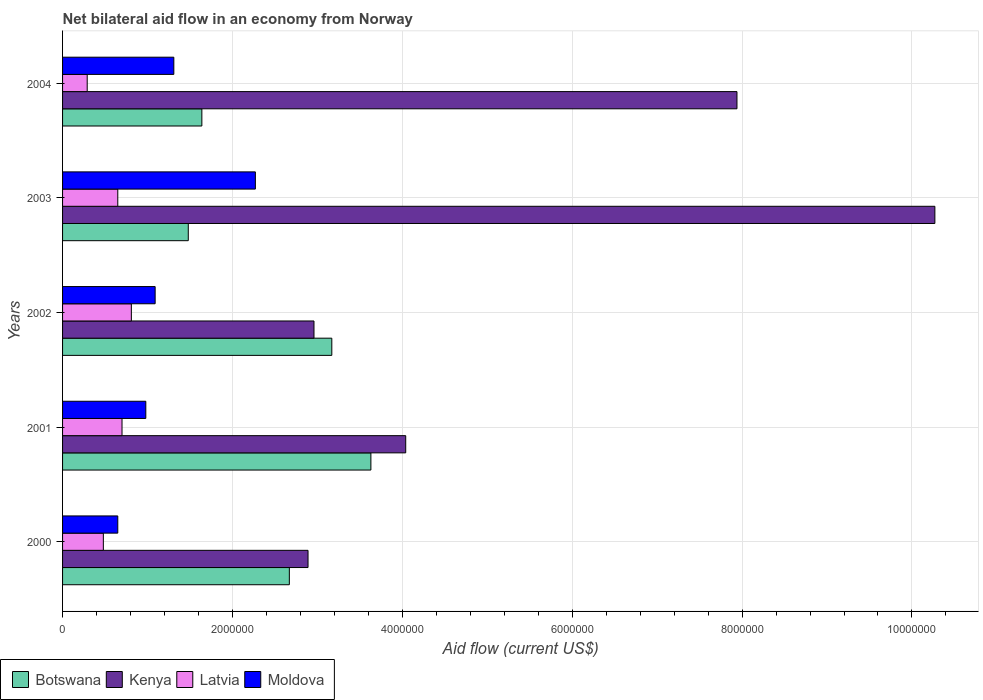Are the number of bars on each tick of the Y-axis equal?
Give a very brief answer. Yes. How many bars are there on the 5th tick from the top?
Give a very brief answer. 4. How many bars are there on the 4th tick from the bottom?
Your response must be concise. 4. What is the label of the 4th group of bars from the top?
Your answer should be very brief. 2001. What is the net bilateral aid flow in Moldova in 2003?
Make the answer very short. 2.27e+06. Across all years, what is the maximum net bilateral aid flow in Botswana?
Keep it short and to the point. 3.63e+06. Across all years, what is the minimum net bilateral aid flow in Kenya?
Ensure brevity in your answer.  2.89e+06. In which year was the net bilateral aid flow in Latvia maximum?
Provide a short and direct response. 2002. In which year was the net bilateral aid flow in Latvia minimum?
Make the answer very short. 2004. What is the total net bilateral aid flow in Botswana in the graph?
Provide a short and direct response. 1.26e+07. What is the difference between the net bilateral aid flow in Latvia in 2001 and that in 2002?
Offer a very short reply. -1.10e+05. What is the difference between the net bilateral aid flow in Kenya in 2003 and the net bilateral aid flow in Moldova in 2002?
Provide a short and direct response. 9.18e+06. What is the average net bilateral aid flow in Botswana per year?
Provide a short and direct response. 2.52e+06. In the year 2001, what is the difference between the net bilateral aid flow in Latvia and net bilateral aid flow in Moldova?
Offer a terse response. -2.80e+05. What is the ratio of the net bilateral aid flow in Botswana in 2000 to that in 2002?
Your response must be concise. 0.84. What is the difference between the highest and the second highest net bilateral aid flow in Kenya?
Give a very brief answer. 2.33e+06. What is the difference between the highest and the lowest net bilateral aid flow in Kenya?
Give a very brief answer. 7.38e+06. What does the 3rd bar from the top in 2000 represents?
Your answer should be very brief. Kenya. What does the 3rd bar from the bottom in 2003 represents?
Make the answer very short. Latvia. Is it the case that in every year, the sum of the net bilateral aid flow in Botswana and net bilateral aid flow in Moldova is greater than the net bilateral aid flow in Latvia?
Your response must be concise. Yes. How many bars are there?
Offer a terse response. 20. How many years are there in the graph?
Ensure brevity in your answer.  5. What is the difference between two consecutive major ticks on the X-axis?
Offer a terse response. 2.00e+06. Are the values on the major ticks of X-axis written in scientific E-notation?
Make the answer very short. No. Where does the legend appear in the graph?
Ensure brevity in your answer.  Bottom left. What is the title of the graph?
Make the answer very short. Net bilateral aid flow in an economy from Norway. Does "Comoros" appear as one of the legend labels in the graph?
Keep it short and to the point. No. What is the label or title of the Y-axis?
Your answer should be compact. Years. What is the Aid flow (current US$) of Botswana in 2000?
Your answer should be compact. 2.67e+06. What is the Aid flow (current US$) of Kenya in 2000?
Your response must be concise. 2.89e+06. What is the Aid flow (current US$) in Latvia in 2000?
Your answer should be compact. 4.80e+05. What is the Aid flow (current US$) of Moldova in 2000?
Offer a terse response. 6.50e+05. What is the Aid flow (current US$) of Botswana in 2001?
Your response must be concise. 3.63e+06. What is the Aid flow (current US$) of Kenya in 2001?
Make the answer very short. 4.04e+06. What is the Aid flow (current US$) in Moldova in 2001?
Your answer should be compact. 9.80e+05. What is the Aid flow (current US$) in Botswana in 2002?
Your answer should be very brief. 3.17e+06. What is the Aid flow (current US$) of Kenya in 2002?
Your answer should be very brief. 2.96e+06. What is the Aid flow (current US$) in Latvia in 2002?
Give a very brief answer. 8.10e+05. What is the Aid flow (current US$) of Moldova in 2002?
Make the answer very short. 1.09e+06. What is the Aid flow (current US$) of Botswana in 2003?
Offer a very short reply. 1.48e+06. What is the Aid flow (current US$) in Kenya in 2003?
Offer a terse response. 1.03e+07. What is the Aid flow (current US$) of Latvia in 2003?
Your answer should be compact. 6.50e+05. What is the Aid flow (current US$) in Moldova in 2003?
Offer a very short reply. 2.27e+06. What is the Aid flow (current US$) of Botswana in 2004?
Keep it short and to the point. 1.64e+06. What is the Aid flow (current US$) in Kenya in 2004?
Provide a succinct answer. 7.94e+06. What is the Aid flow (current US$) in Latvia in 2004?
Offer a terse response. 2.90e+05. What is the Aid flow (current US$) of Moldova in 2004?
Provide a succinct answer. 1.31e+06. Across all years, what is the maximum Aid flow (current US$) of Botswana?
Offer a very short reply. 3.63e+06. Across all years, what is the maximum Aid flow (current US$) in Kenya?
Offer a very short reply. 1.03e+07. Across all years, what is the maximum Aid flow (current US$) in Latvia?
Your answer should be compact. 8.10e+05. Across all years, what is the maximum Aid flow (current US$) of Moldova?
Provide a succinct answer. 2.27e+06. Across all years, what is the minimum Aid flow (current US$) in Botswana?
Your response must be concise. 1.48e+06. Across all years, what is the minimum Aid flow (current US$) in Kenya?
Your answer should be compact. 2.89e+06. Across all years, what is the minimum Aid flow (current US$) in Moldova?
Provide a succinct answer. 6.50e+05. What is the total Aid flow (current US$) of Botswana in the graph?
Provide a short and direct response. 1.26e+07. What is the total Aid flow (current US$) in Kenya in the graph?
Provide a short and direct response. 2.81e+07. What is the total Aid flow (current US$) in Latvia in the graph?
Your answer should be very brief. 2.93e+06. What is the total Aid flow (current US$) in Moldova in the graph?
Provide a succinct answer. 6.30e+06. What is the difference between the Aid flow (current US$) of Botswana in 2000 and that in 2001?
Your answer should be compact. -9.60e+05. What is the difference between the Aid flow (current US$) of Kenya in 2000 and that in 2001?
Give a very brief answer. -1.15e+06. What is the difference between the Aid flow (current US$) of Moldova in 2000 and that in 2001?
Your answer should be compact. -3.30e+05. What is the difference between the Aid flow (current US$) in Botswana in 2000 and that in 2002?
Make the answer very short. -5.00e+05. What is the difference between the Aid flow (current US$) in Kenya in 2000 and that in 2002?
Provide a short and direct response. -7.00e+04. What is the difference between the Aid flow (current US$) in Latvia in 2000 and that in 2002?
Give a very brief answer. -3.30e+05. What is the difference between the Aid flow (current US$) of Moldova in 2000 and that in 2002?
Your answer should be compact. -4.40e+05. What is the difference between the Aid flow (current US$) in Botswana in 2000 and that in 2003?
Your answer should be very brief. 1.19e+06. What is the difference between the Aid flow (current US$) of Kenya in 2000 and that in 2003?
Provide a short and direct response. -7.38e+06. What is the difference between the Aid flow (current US$) of Latvia in 2000 and that in 2003?
Offer a terse response. -1.70e+05. What is the difference between the Aid flow (current US$) in Moldova in 2000 and that in 2003?
Your answer should be compact. -1.62e+06. What is the difference between the Aid flow (current US$) in Botswana in 2000 and that in 2004?
Make the answer very short. 1.03e+06. What is the difference between the Aid flow (current US$) in Kenya in 2000 and that in 2004?
Provide a succinct answer. -5.05e+06. What is the difference between the Aid flow (current US$) in Latvia in 2000 and that in 2004?
Provide a short and direct response. 1.90e+05. What is the difference between the Aid flow (current US$) of Moldova in 2000 and that in 2004?
Ensure brevity in your answer.  -6.60e+05. What is the difference between the Aid flow (current US$) of Kenya in 2001 and that in 2002?
Provide a short and direct response. 1.08e+06. What is the difference between the Aid flow (current US$) of Moldova in 2001 and that in 2002?
Offer a very short reply. -1.10e+05. What is the difference between the Aid flow (current US$) in Botswana in 2001 and that in 2003?
Your answer should be compact. 2.15e+06. What is the difference between the Aid flow (current US$) in Kenya in 2001 and that in 2003?
Give a very brief answer. -6.23e+06. What is the difference between the Aid flow (current US$) in Latvia in 2001 and that in 2003?
Ensure brevity in your answer.  5.00e+04. What is the difference between the Aid flow (current US$) in Moldova in 2001 and that in 2003?
Keep it short and to the point. -1.29e+06. What is the difference between the Aid flow (current US$) in Botswana in 2001 and that in 2004?
Your answer should be very brief. 1.99e+06. What is the difference between the Aid flow (current US$) of Kenya in 2001 and that in 2004?
Provide a short and direct response. -3.90e+06. What is the difference between the Aid flow (current US$) in Latvia in 2001 and that in 2004?
Your response must be concise. 4.10e+05. What is the difference between the Aid flow (current US$) in Moldova in 2001 and that in 2004?
Provide a short and direct response. -3.30e+05. What is the difference between the Aid flow (current US$) in Botswana in 2002 and that in 2003?
Provide a short and direct response. 1.69e+06. What is the difference between the Aid flow (current US$) in Kenya in 2002 and that in 2003?
Your answer should be very brief. -7.31e+06. What is the difference between the Aid flow (current US$) in Latvia in 2002 and that in 2003?
Offer a terse response. 1.60e+05. What is the difference between the Aid flow (current US$) of Moldova in 2002 and that in 2003?
Offer a terse response. -1.18e+06. What is the difference between the Aid flow (current US$) in Botswana in 2002 and that in 2004?
Offer a very short reply. 1.53e+06. What is the difference between the Aid flow (current US$) in Kenya in 2002 and that in 2004?
Offer a terse response. -4.98e+06. What is the difference between the Aid flow (current US$) of Latvia in 2002 and that in 2004?
Your answer should be compact. 5.20e+05. What is the difference between the Aid flow (current US$) in Kenya in 2003 and that in 2004?
Provide a short and direct response. 2.33e+06. What is the difference between the Aid flow (current US$) of Moldova in 2003 and that in 2004?
Ensure brevity in your answer.  9.60e+05. What is the difference between the Aid flow (current US$) in Botswana in 2000 and the Aid flow (current US$) in Kenya in 2001?
Ensure brevity in your answer.  -1.37e+06. What is the difference between the Aid flow (current US$) of Botswana in 2000 and the Aid flow (current US$) of Latvia in 2001?
Give a very brief answer. 1.97e+06. What is the difference between the Aid flow (current US$) in Botswana in 2000 and the Aid flow (current US$) in Moldova in 2001?
Your response must be concise. 1.69e+06. What is the difference between the Aid flow (current US$) of Kenya in 2000 and the Aid flow (current US$) of Latvia in 2001?
Provide a succinct answer. 2.19e+06. What is the difference between the Aid flow (current US$) in Kenya in 2000 and the Aid flow (current US$) in Moldova in 2001?
Keep it short and to the point. 1.91e+06. What is the difference between the Aid flow (current US$) of Latvia in 2000 and the Aid flow (current US$) of Moldova in 2001?
Offer a very short reply. -5.00e+05. What is the difference between the Aid flow (current US$) in Botswana in 2000 and the Aid flow (current US$) in Latvia in 2002?
Offer a terse response. 1.86e+06. What is the difference between the Aid flow (current US$) in Botswana in 2000 and the Aid flow (current US$) in Moldova in 2002?
Keep it short and to the point. 1.58e+06. What is the difference between the Aid flow (current US$) of Kenya in 2000 and the Aid flow (current US$) of Latvia in 2002?
Offer a very short reply. 2.08e+06. What is the difference between the Aid flow (current US$) of Kenya in 2000 and the Aid flow (current US$) of Moldova in 2002?
Provide a short and direct response. 1.80e+06. What is the difference between the Aid flow (current US$) of Latvia in 2000 and the Aid flow (current US$) of Moldova in 2002?
Keep it short and to the point. -6.10e+05. What is the difference between the Aid flow (current US$) in Botswana in 2000 and the Aid flow (current US$) in Kenya in 2003?
Make the answer very short. -7.60e+06. What is the difference between the Aid flow (current US$) in Botswana in 2000 and the Aid flow (current US$) in Latvia in 2003?
Keep it short and to the point. 2.02e+06. What is the difference between the Aid flow (current US$) in Kenya in 2000 and the Aid flow (current US$) in Latvia in 2003?
Ensure brevity in your answer.  2.24e+06. What is the difference between the Aid flow (current US$) in Kenya in 2000 and the Aid flow (current US$) in Moldova in 2003?
Your answer should be very brief. 6.20e+05. What is the difference between the Aid flow (current US$) in Latvia in 2000 and the Aid flow (current US$) in Moldova in 2003?
Make the answer very short. -1.79e+06. What is the difference between the Aid flow (current US$) in Botswana in 2000 and the Aid flow (current US$) in Kenya in 2004?
Your answer should be compact. -5.27e+06. What is the difference between the Aid flow (current US$) in Botswana in 2000 and the Aid flow (current US$) in Latvia in 2004?
Give a very brief answer. 2.38e+06. What is the difference between the Aid flow (current US$) in Botswana in 2000 and the Aid flow (current US$) in Moldova in 2004?
Give a very brief answer. 1.36e+06. What is the difference between the Aid flow (current US$) of Kenya in 2000 and the Aid flow (current US$) of Latvia in 2004?
Your response must be concise. 2.60e+06. What is the difference between the Aid flow (current US$) of Kenya in 2000 and the Aid flow (current US$) of Moldova in 2004?
Give a very brief answer. 1.58e+06. What is the difference between the Aid flow (current US$) of Latvia in 2000 and the Aid flow (current US$) of Moldova in 2004?
Provide a succinct answer. -8.30e+05. What is the difference between the Aid flow (current US$) in Botswana in 2001 and the Aid flow (current US$) in Kenya in 2002?
Give a very brief answer. 6.70e+05. What is the difference between the Aid flow (current US$) in Botswana in 2001 and the Aid flow (current US$) in Latvia in 2002?
Your answer should be compact. 2.82e+06. What is the difference between the Aid flow (current US$) of Botswana in 2001 and the Aid flow (current US$) of Moldova in 2002?
Your answer should be compact. 2.54e+06. What is the difference between the Aid flow (current US$) of Kenya in 2001 and the Aid flow (current US$) of Latvia in 2002?
Provide a short and direct response. 3.23e+06. What is the difference between the Aid flow (current US$) of Kenya in 2001 and the Aid flow (current US$) of Moldova in 2002?
Offer a very short reply. 2.95e+06. What is the difference between the Aid flow (current US$) of Latvia in 2001 and the Aid flow (current US$) of Moldova in 2002?
Provide a succinct answer. -3.90e+05. What is the difference between the Aid flow (current US$) of Botswana in 2001 and the Aid flow (current US$) of Kenya in 2003?
Provide a succinct answer. -6.64e+06. What is the difference between the Aid flow (current US$) in Botswana in 2001 and the Aid flow (current US$) in Latvia in 2003?
Provide a succinct answer. 2.98e+06. What is the difference between the Aid flow (current US$) in Botswana in 2001 and the Aid flow (current US$) in Moldova in 2003?
Keep it short and to the point. 1.36e+06. What is the difference between the Aid flow (current US$) of Kenya in 2001 and the Aid flow (current US$) of Latvia in 2003?
Give a very brief answer. 3.39e+06. What is the difference between the Aid flow (current US$) of Kenya in 2001 and the Aid flow (current US$) of Moldova in 2003?
Provide a short and direct response. 1.77e+06. What is the difference between the Aid flow (current US$) in Latvia in 2001 and the Aid flow (current US$) in Moldova in 2003?
Provide a short and direct response. -1.57e+06. What is the difference between the Aid flow (current US$) of Botswana in 2001 and the Aid flow (current US$) of Kenya in 2004?
Your answer should be compact. -4.31e+06. What is the difference between the Aid flow (current US$) in Botswana in 2001 and the Aid flow (current US$) in Latvia in 2004?
Make the answer very short. 3.34e+06. What is the difference between the Aid flow (current US$) of Botswana in 2001 and the Aid flow (current US$) of Moldova in 2004?
Provide a succinct answer. 2.32e+06. What is the difference between the Aid flow (current US$) in Kenya in 2001 and the Aid flow (current US$) in Latvia in 2004?
Provide a succinct answer. 3.75e+06. What is the difference between the Aid flow (current US$) of Kenya in 2001 and the Aid flow (current US$) of Moldova in 2004?
Your answer should be very brief. 2.73e+06. What is the difference between the Aid flow (current US$) of Latvia in 2001 and the Aid flow (current US$) of Moldova in 2004?
Your answer should be very brief. -6.10e+05. What is the difference between the Aid flow (current US$) in Botswana in 2002 and the Aid flow (current US$) in Kenya in 2003?
Keep it short and to the point. -7.10e+06. What is the difference between the Aid flow (current US$) of Botswana in 2002 and the Aid flow (current US$) of Latvia in 2003?
Your answer should be very brief. 2.52e+06. What is the difference between the Aid flow (current US$) of Botswana in 2002 and the Aid flow (current US$) of Moldova in 2003?
Provide a short and direct response. 9.00e+05. What is the difference between the Aid flow (current US$) in Kenya in 2002 and the Aid flow (current US$) in Latvia in 2003?
Your answer should be very brief. 2.31e+06. What is the difference between the Aid flow (current US$) in Kenya in 2002 and the Aid flow (current US$) in Moldova in 2003?
Ensure brevity in your answer.  6.90e+05. What is the difference between the Aid flow (current US$) of Latvia in 2002 and the Aid flow (current US$) of Moldova in 2003?
Your answer should be compact. -1.46e+06. What is the difference between the Aid flow (current US$) of Botswana in 2002 and the Aid flow (current US$) of Kenya in 2004?
Keep it short and to the point. -4.77e+06. What is the difference between the Aid flow (current US$) in Botswana in 2002 and the Aid flow (current US$) in Latvia in 2004?
Your response must be concise. 2.88e+06. What is the difference between the Aid flow (current US$) of Botswana in 2002 and the Aid flow (current US$) of Moldova in 2004?
Your response must be concise. 1.86e+06. What is the difference between the Aid flow (current US$) in Kenya in 2002 and the Aid flow (current US$) in Latvia in 2004?
Your answer should be compact. 2.67e+06. What is the difference between the Aid flow (current US$) in Kenya in 2002 and the Aid flow (current US$) in Moldova in 2004?
Make the answer very short. 1.65e+06. What is the difference between the Aid flow (current US$) of Latvia in 2002 and the Aid flow (current US$) of Moldova in 2004?
Provide a succinct answer. -5.00e+05. What is the difference between the Aid flow (current US$) of Botswana in 2003 and the Aid flow (current US$) of Kenya in 2004?
Give a very brief answer. -6.46e+06. What is the difference between the Aid flow (current US$) in Botswana in 2003 and the Aid flow (current US$) in Latvia in 2004?
Ensure brevity in your answer.  1.19e+06. What is the difference between the Aid flow (current US$) in Kenya in 2003 and the Aid flow (current US$) in Latvia in 2004?
Keep it short and to the point. 9.98e+06. What is the difference between the Aid flow (current US$) in Kenya in 2003 and the Aid flow (current US$) in Moldova in 2004?
Your answer should be very brief. 8.96e+06. What is the difference between the Aid flow (current US$) of Latvia in 2003 and the Aid flow (current US$) of Moldova in 2004?
Your answer should be compact. -6.60e+05. What is the average Aid flow (current US$) in Botswana per year?
Make the answer very short. 2.52e+06. What is the average Aid flow (current US$) in Kenya per year?
Keep it short and to the point. 5.62e+06. What is the average Aid flow (current US$) of Latvia per year?
Provide a short and direct response. 5.86e+05. What is the average Aid flow (current US$) in Moldova per year?
Offer a terse response. 1.26e+06. In the year 2000, what is the difference between the Aid flow (current US$) of Botswana and Aid flow (current US$) of Latvia?
Your answer should be compact. 2.19e+06. In the year 2000, what is the difference between the Aid flow (current US$) in Botswana and Aid flow (current US$) in Moldova?
Provide a succinct answer. 2.02e+06. In the year 2000, what is the difference between the Aid flow (current US$) of Kenya and Aid flow (current US$) of Latvia?
Offer a terse response. 2.41e+06. In the year 2000, what is the difference between the Aid flow (current US$) of Kenya and Aid flow (current US$) of Moldova?
Your response must be concise. 2.24e+06. In the year 2001, what is the difference between the Aid flow (current US$) of Botswana and Aid flow (current US$) of Kenya?
Ensure brevity in your answer.  -4.10e+05. In the year 2001, what is the difference between the Aid flow (current US$) in Botswana and Aid flow (current US$) in Latvia?
Make the answer very short. 2.93e+06. In the year 2001, what is the difference between the Aid flow (current US$) of Botswana and Aid flow (current US$) of Moldova?
Make the answer very short. 2.65e+06. In the year 2001, what is the difference between the Aid flow (current US$) in Kenya and Aid flow (current US$) in Latvia?
Provide a succinct answer. 3.34e+06. In the year 2001, what is the difference between the Aid flow (current US$) in Kenya and Aid flow (current US$) in Moldova?
Your response must be concise. 3.06e+06. In the year 2001, what is the difference between the Aid flow (current US$) of Latvia and Aid flow (current US$) of Moldova?
Your answer should be very brief. -2.80e+05. In the year 2002, what is the difference between the Aid flow (current US$) of Botswana and Aid flow (current US$) of Kenya?
Your answer should be very brief. 2.10e+05. In the year 2002, what is the difference between the Aid flow (current US$) in Botswana and Aid flow (current US$) in Latvia?
Offer a very short reply. 2.36e+06. In the year 2002, what is the difference between the Aid flow (current US$) of Botswana and Aid flow (current US$) of Moldova?
Give a very brief answer. 2.08e+06. In the year 2002, what is the difference between the Aid flow (current US$) of Kenya and Aid flow (current US$) of Latvia?
Your answer should be very brief. 2.15e+06. In the year 2002, what is the difference between the Aid flow (current US$) in Kenya and Aid flow (current US$) in Moldova?
Offer a very short reply. 1.87e+06. In the year 2002, what is the difference between the Aid flow (current US$) of Latvia and Aid flow (current US$) of Moldova?
Offer a very short reply. -2.80e+05. In the year 2003, what is the difference between the Aid flow (current US$) of Botswana and Aid flow (current US$) of Kenya?
Provide a succinct answer. -8.79e+06. In the year 2003, what is the difference between the Aid flow (current US$) of Botswana and Aid flow (current US$) of Latvia?
Provide a short and direct response. 8.30e+05. In the year 2003, what is the difference between the Aid flow (current US$) of Botswana and Aid flow (current US$) of Moldova?
Keep it short and to the point. -7.90e+05. In the year 2003, what is the difference between the Aid flow (current US$) of Kenya and Aid flow (current US$) of Latvia?
Give a very brief answer. 9.62e+06. In the year 2003, what is the difference between the Aid flow (current US$) of Latvia and Aid flow (current US$) of Moldova?
Offer a very short reply. -1.62e+06. In the year 2004, what is the difference between the Aid flow (current US$) in Botswana and Aid flow (current US$) in Kenya?
Provide a short and direct response. -6.30e+06. In the year 2004, what is the difference between the Aid flow (current US$) in Botswana and Aid flow (current US$) in Latvia?
Provide a succinct answer. 1.35e+06. In the year 2004, what is the difference between the Aid flow (current US$) of Kenya and Aid flow (current US$) of Latvia?
Your answer should be compact. 7.65e+06. In the year 2004, what is the difference between the Aid flow (current US$) in Kenya and Aid flow (current US$) in Moldova?
Your response must be concise. 6.63e+06. In the year 2004, what is the difference between the Aid flow (current US$) in Latvia and Aid flow (current US$) in Moldova?
Your answer should be compact. -1.02e+06. What is the ratio of the Aid flow (current US$) in Botswana in 2000 to that in 2001?
Offer a very short reply. 0.74. What is the ratio of the Aid flow (current US$) in Kenya in 2000 to that in 2001?
Provide a succinct answer. 0.72. What is the ratio of the Aid flow (current US$) of Latvia in 2000 to that in 2001?
Your answer should be compact. 0.69. What is the ratio of the Aid flow (current US$) of Moldova in 2000 to that in 2001?
Your response must be concise. 0.66. What is the ratio of the Aid flow (current US$) in Botswana in 2000 to that in 2002?
Keep it short and to the point. 0.84. What is the ratio of the Aid flow (current US$) of Kenya in 2000 to that in 2002?
Offer a very short reply. 0.98. What is the ratio of the Aid flow (current US$) in Latvia in 2000 to that in 2002?
Ensure brevity in your answer.  0.59. What is the ratio of the Aid flow (current US$) of Moldova in 2000 to that in 2002?
Give a very brief answer. 0.6. What is the ratio of the Aid flow (current US$) of Botswana in 2000 to that in 2003?
Ensure brevity in your answer.  1.8. What is the ratio of the Aid flow (current US$) in Kenya in 2000 to that in 2003?
Offer a very short reply. 0.28. What is the ratio of the Aid flow (current US$) of Latvia in 2000 to that in 2003?
Your answer should be compact. 0.74. What is the ratio of the Aid flow (current US$) of Moldova in 2000 to that in 2003?
Give a very brief answer. 0.29. What is the ratio of the Aid flow (current US$) of Botswana in 2000 to that in 2004?
Provide a succinct answer. 1.63. What is the ratio of the Aid flow (current US$) of Kenya in 2000 to that in 2004?
Your answer should be compact. 0.36. What is the ratio of the Aid flow (current US$) in Latvia in 2000 to that in 2004?
Keep it short and to the point. 1.66. What is the ratio of the Aid flow (current US$) in Moldova in 2000 to that in 2004?
Provide a short and direct response. 0.5. What is the ratio of the Aid flow (current US$) of Botswana in 2001 to that in 2002?
Make the answer very short. 1.15. What is the ratio of the Aid flow (current US$) of Kenya in 2001 to that in 2002?
Provide a succinct answer. 1.36. What is the ratio of the Aid flow (current US$) of Latvia in 2001 to that in 2002?
Your answer should be very brief. 0.86. What is the ratio of the Aid flow (current US$) in Moldova in 2001 to that in 2002?
Ensure brevity in your answer.  0.9. What is the ratio of the Aid flow (current US$) of Botswana in 2001 to that in 2003?
Your answer should be very brief. 2.45. What is the ratio of the Aid flow (current US$) in Kenya in 2001 to that in 2003?
Make the answer very short. 0.39. What is the ratio of the Aid flow (current US$) of Latvia in 2001 to that in 2003?
Keep it short and to the point. 1.08. What is the ratio of the Aid flow (current US$) of Moldova in 2001 to that in 2003?
Provide a succinct answer. 0.43. What is the ratio of the Aid flow (current US$) of Botswana in 2001 to that in 2004?
Offer a terse response. 2.21. What is the ratio of the Aid flow (current US$) of Kenya in 2001 to that in 2004?
Keep it short and to the point. 0.51. What is the ratio of the Aid flow (current US$) of Latvia in 2001 to that in 2004?
Offer a terse response. 2.41. What is the ratio of the Aid flow (current US$) in Moldova in 2001 to that in 2004?
Your answer should be compact. 0.75. What is the ratio of the Aid flow (current US$) in Botswana in 2002 to that in 2003?
Give a very brief answer. 2.14. What is the ratio of the Aid flow (current US$) of Kenya in 2002 to that in 2003?
Provide a short and direct response. 0.29. What is the ratio of the Aid flow (current US$) in Latvia in 2002 to that in 2003?
Give a very brief answer. 1.25. What is the ratio of the Aid flow (current US$) of Moldova in 2002 to that in 2003?
Your answer should be very brief. 0.48. What is the ratio of the Aid flow (current US$) of Botswana in 2002 to that in 2004?
Ensure brevity in your answer.  1.93. What is the ratio of the Aid flow (current US$) of Kenya in 2002 to that in 2004?
Provide a short and direct response. 0.37. What is the ratio of the Aid flow (current US$) in Latvia in 2002 to that in 2004?
Ensure brevity in your answer.  2.79. What is the ratio of the Aid flow (current US$) in Moldova in 2002 to that in 2004?
Provide a succinct answer. 0.83. What is the ratio of the Aid flow (current US$) of Botswana in 2003 to that in 2004?
Keep it short and to the point. 0.9. What is the ratio of the Aid flow (current US$) of Kenya in 2003 to that in 2004?
Provide a succinct answer. 1.29. What is the ratio of the Aid flow (current US$) in Latvia in 2003 to that in 2004?
Your answer should be compact. 2.24. What is the ratio of the Aid flow (current US$) in Moldova in 2003 to that in 2004?
Offer a very short reply. 1.73. What is the difference between the highest and the second highest Aid flow (current US$) in Botswana?
Ensure brevity in your answer.  4.60e+05. What is the difference between the highest and the second highest Aid flow (current US$) in Kenya?
Keep it short and to the point. 2.33e+06. What is the difference between the highest and the second highest Aid flow (current US$) in Latvia?
Keep it short and to the point. 1.10e+05. What is the difference between the highest and the second highest Aid flow (current US$) of Moldova?
Provide a succinct answer. 9.60e+05. What is the difference between the highest and the lowest Aid flow (current US$) of Botswana?
Provide a short and direct response. 2.15e+06. What is the difference between the highest and the lowest Aid flow (current US$) of Kenya?
Ensure brevity in your answer.  7.38e+06. What is the difference between the highest and the lowest Aid flow (current US$) in Latvia?
Your answer should be compact. 5.20e+05. What is the difference between the highest and the lowest Aid flow (current US$) in Moldova?
Provide a short and direct response. 1.62e+06. 